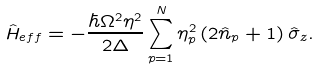Convert formula to latex. <formula><loc_0><loc_0><loc_500><loc_500>\hat { H } _ { e f f } = - \frac { \hbar { \Omega } ^ { 2 } \eta ^ { 2 } } { 2 \Delta } \sum _ { p = 1 } ^ { N } \eta ^ { 2 } _ { p } \left ( 2 \hat { n } _ { p } + 1 \right ) \hat { \sigma } _ { z } .</formula> 